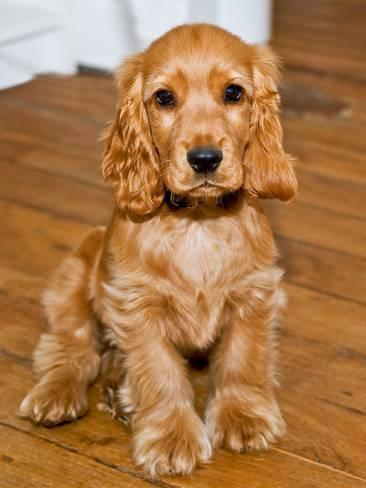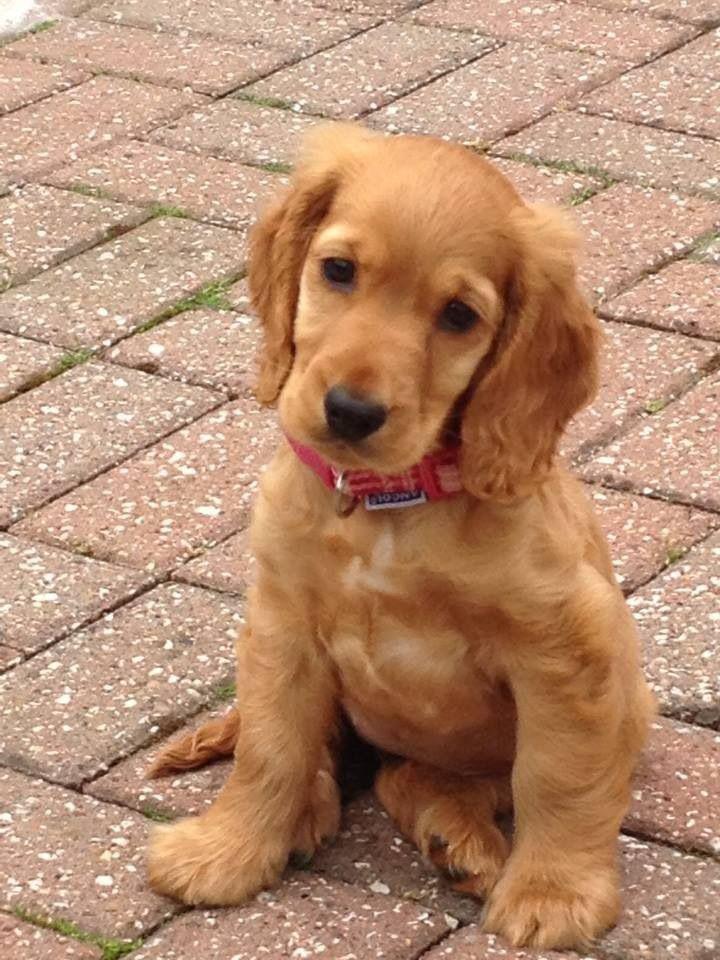The first image is the image on the left, the second image is the image on the right. For the images displayed, is the sentence "An upright cocket spaniel is outdoors and has its tongue extended but not licking its nose." factually correct? Answer yes or no. No. The first image is the image on the left, the second image is the image on the right. For the images shown, is this caption "A single dog is on grass" true? Answer yes or no. No. 